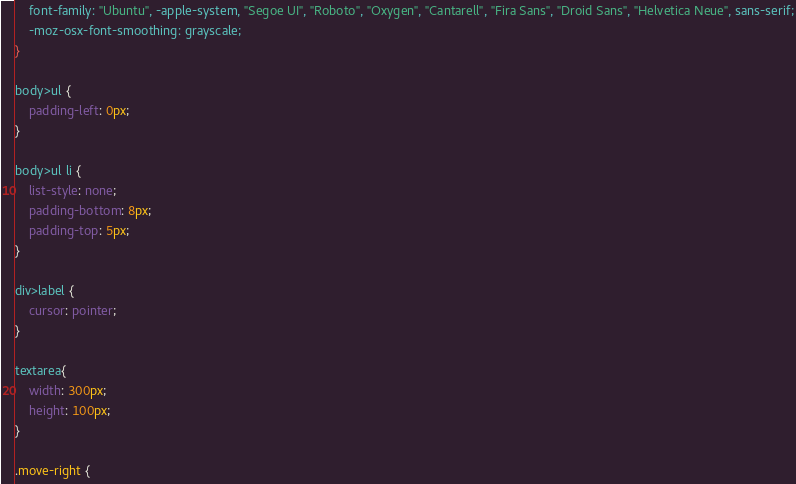<code> <loc_0><loc_0><loc_500><loc_500><_CSS_>	font-family: "Ubuntu", -apple-system, "Segoe UI", "Roboto", "Oxygen", "Cantarell", "Fira Sans", "Droid Sans", "Helvetica Neue", sans-serif;
	-moz-osx-font-smoothing: grayscale;
}

body>ul {
	padding-left: 0px;
}

body>ul li {
	list-style: none;
	padding-bottom: 8px;
	padding-top: 5px;
}

div>label {
	cursor: pointer;
}

textarea{
	width: 300px;
	height: 100px;
}

.move-right {</code> 